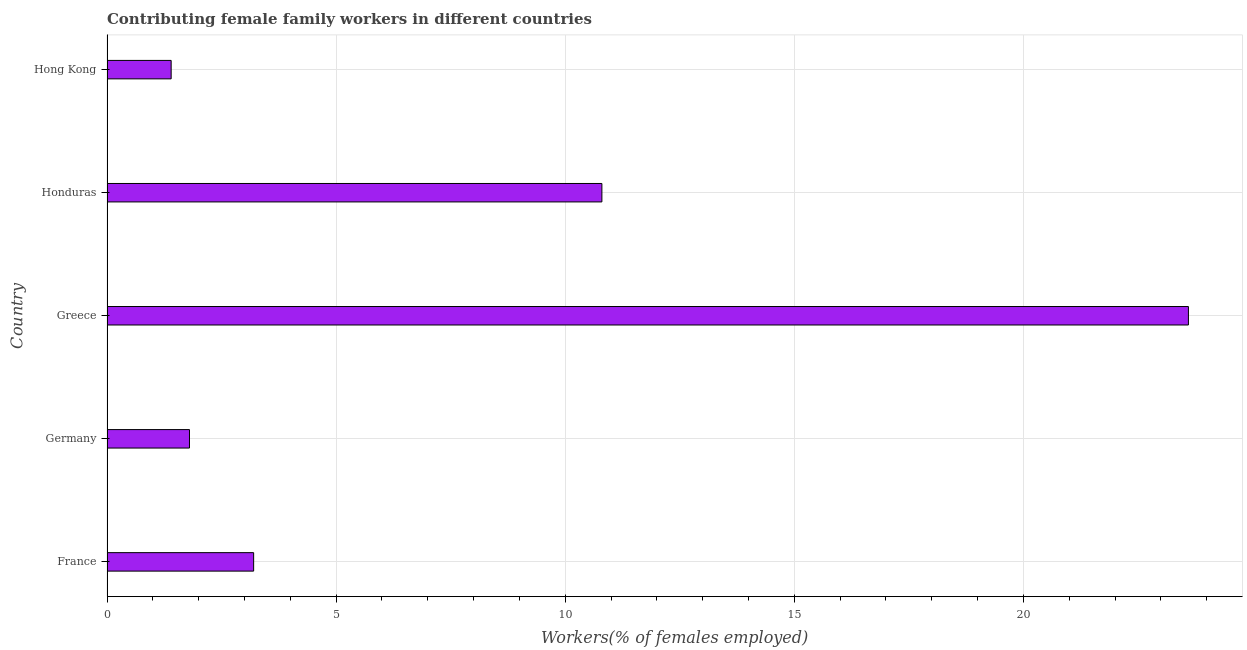Does the graph contain grids?
Make the answer very short. Yes. What is the title of the graph?
Provide a succinct answer. Contributing female family workers in different countries. What is the label or title of the X-axis?
Make the answer very short. Workers(% of females employed). What is the contributing female family workers in Greece?
Ensure brevity in your answer.  23.6. Across all countries, what is the maximum contributing female family workers?
Your answer should be compact. 23.6. Across all countries, what is the minimum contributing female family workers?
Offer a very short reply. 1.4. In which country was the contributing female family workers minimum?
Offer a terse response. Hong Kong. What is the sum of the contributing female family workers?
Your response must be concise. 40.8. What is the difference between the contributing female family workers in Germany and Honduras?
Your response must be concise. -9. What is the average contributing female family workers per country?
Your answer should be compact. 8.16. What is the median contributing female family workers?
Provide a short and direct response. 3.2. What is the ratio of the contributing female family workers in Germany to that in Greece?
Offer a terse response. 0.08. Is the contributing female family workers in Germany less than that in Greece?
Your answer should be compact. Yes. Is the sum of the contributing female family workers in France and Greece greater than the maximum contributing female family workers across all countries?
Keep it short and to the point. Yes. In how many countries, is the contributing female family workers greater than the average contributing female family workers taken over all countries?
Offer a terse response. 2. Are all the bars in the graph horizontal?
Offer a very short reply. Yes. What is the Workers(% of females employed) in France?
Provide a succinct answer. 3.2. What is the Workers(% of females employed) of Germany?
Your answer should be very brief. 1.8. What is the Workers(% of females employed) in Greece?
Your answer should be very brief. 23.6. What is the Workers(% of females employed) in Honduras?
Make the answer very short. 10.8. What is the Workers(% of females employed) in Hong Kong?
Your answer should be compact. 1.4. What is the difference between the Workers(% of females employed) in France and Greece?
Give a very brief answer. -20.4. What is the difference between the Workers(% of females employed) in France and Hong Kong?
Your response must be concise. 1.8. What is the difference between the Workers(% of females employed) in Germany and Greece?
Make the answer very short. -21.8. What is the difference between the Workers(% of females employed) in Greece and Honduras?
Ensure brevity in your answer.  12.8. What is the difference between the Workers(% of females employed) in Greece and Hong Kong?
Ensure brevity in your answer.  22.2. What is the ratio of the Workers(% of females employed) in France to that in Germany?
Offer a terse response. 1.78. What is the ratio of the Workers(% of females employed) in France to that in Greece?
Your answer should be very brief. 0.14. What is the ratio of the Workers(% of females employed) in France to that in Honduras?
Your answer should be very brief. 0.3. What is the ratio of the Workers(% of females employed) in France to that in Hong Kong?
Provide a short and direct response. 2.29. What is the ratio of the Workers(% of females employed) in Germany to that in Greece?
Provide a short and direct response. 0.08. What is the ratio of the Workers(% of females employed) in Germany to that in Honduras?
Keep it short and to the point. 0.17. What is the ratio of the Workers(% of females employed) in Germany to that in Hong Kong?
Your answer should be very brief. 1.29. What is the ratio of the Workers(% of females employed) in Greece to that in Honduras?
Offer a terse response. 2.19. What is the ratio of the Workers(% of females employed) in Greece to that in Hong Kong?
Provide a short and direct response. 16.86. What is the ratio of the Workers(% of females employed) in Honduras to that in Hong Kong?
Provide a short and direct response. 7.71. 